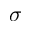Convert formula to latex. <formula><loc_0><loc_0><loc_500><loc_500>\sigma</formula> 